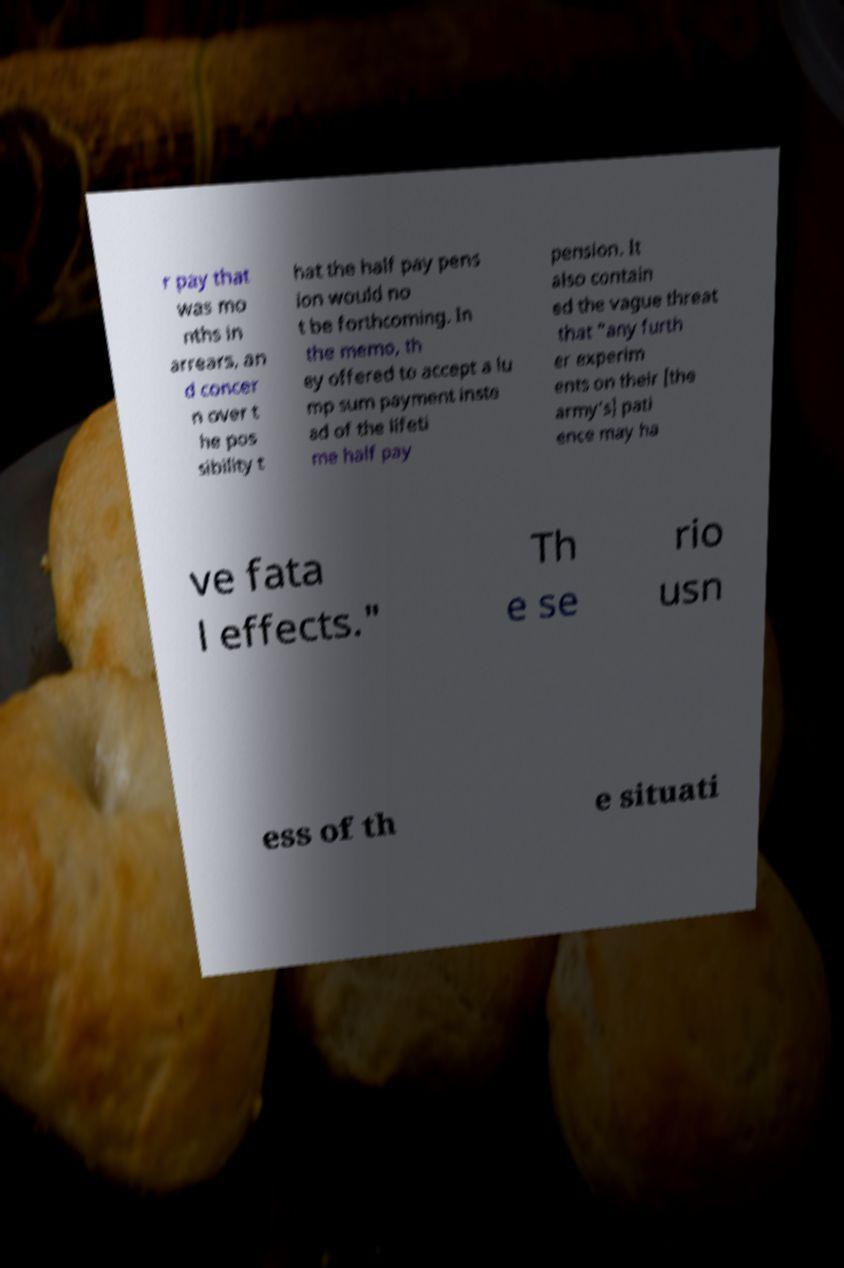Could you assist in decoding the text presented in this image and type it out clearly? r pay that was mo nths in arrears, an d concer n over t he pos sibility t hat the half pay pens ion would no t be forthcoming. In the memo, th ey offered to accept a lu mp sum payment inste ad of the lifeti me half pay pension. It also contain ed the vague threat that "any furth er experim ents on their [the army's] pati ence may ha ve fata l effects." Th e se rio usn ess of th e situati 